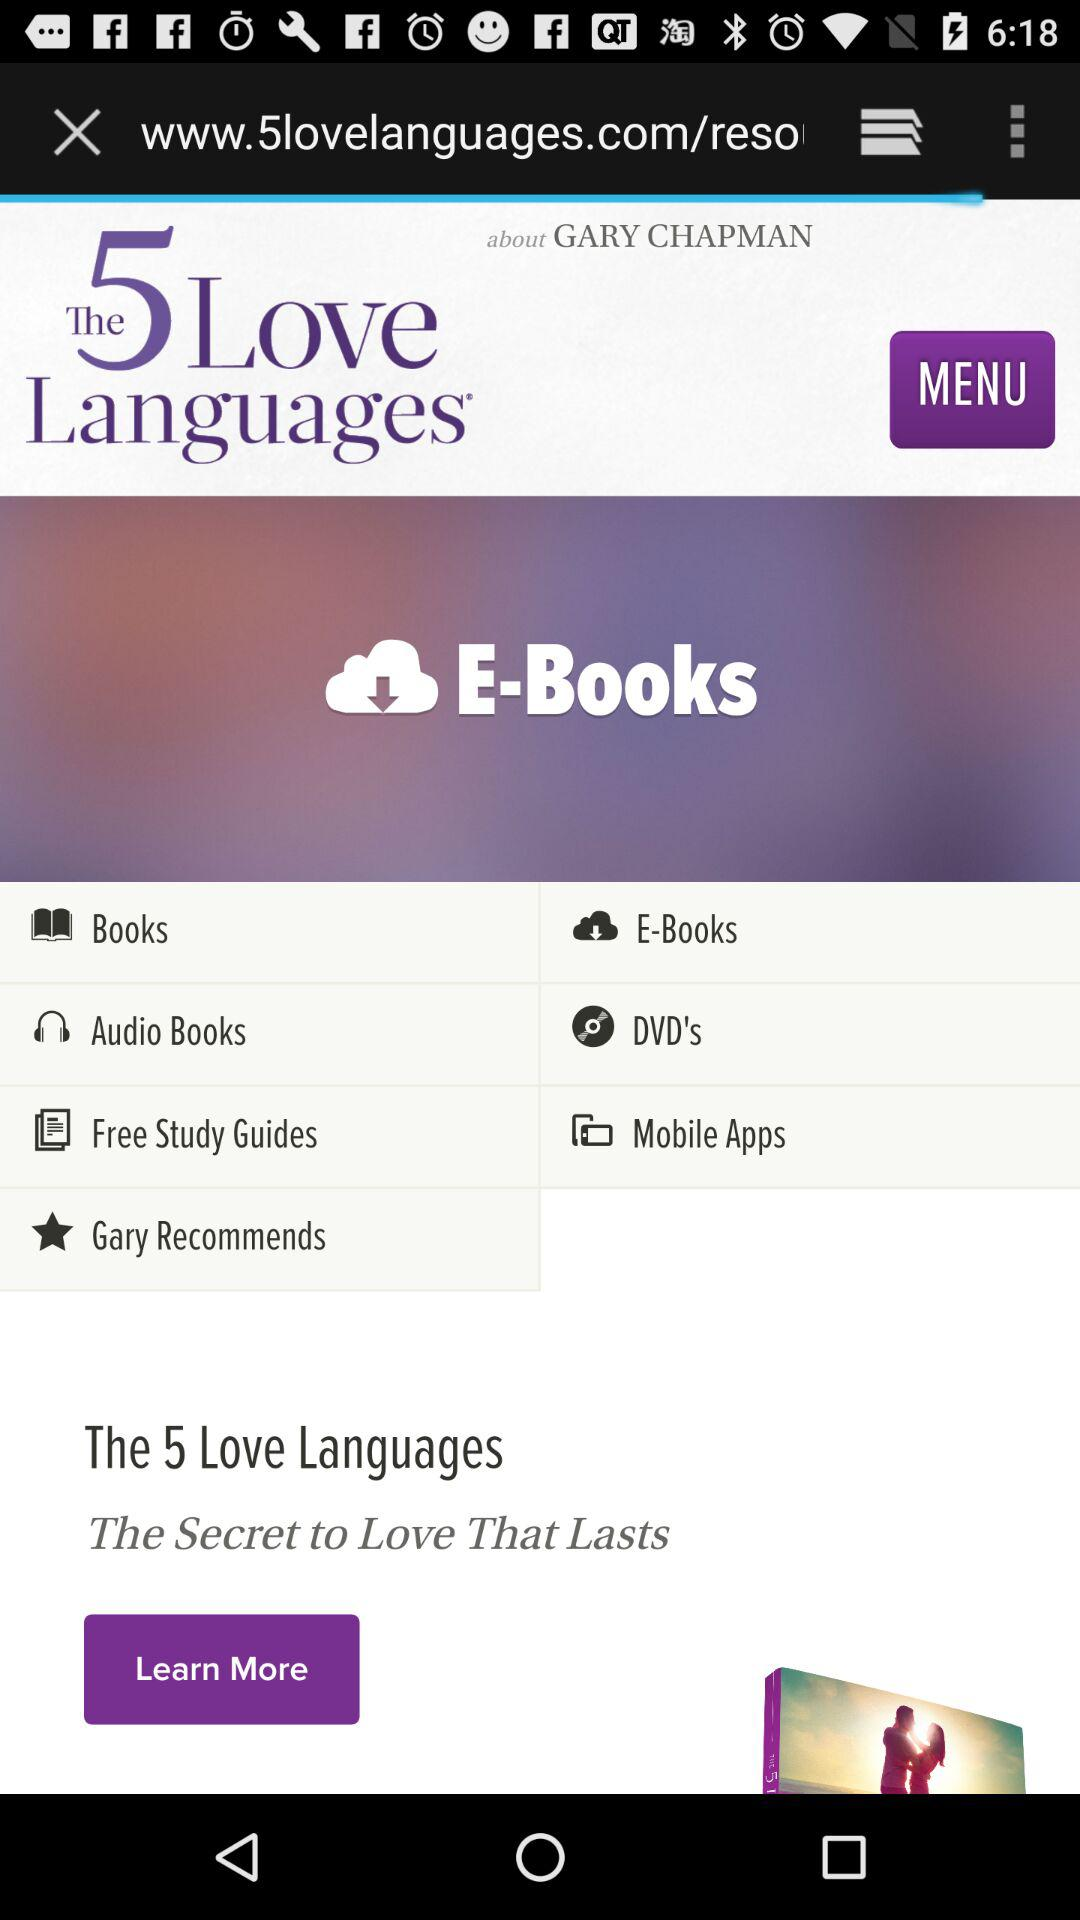What are the available formats of the books? The available formats of the books are "Audio Books" and "E-Books". 